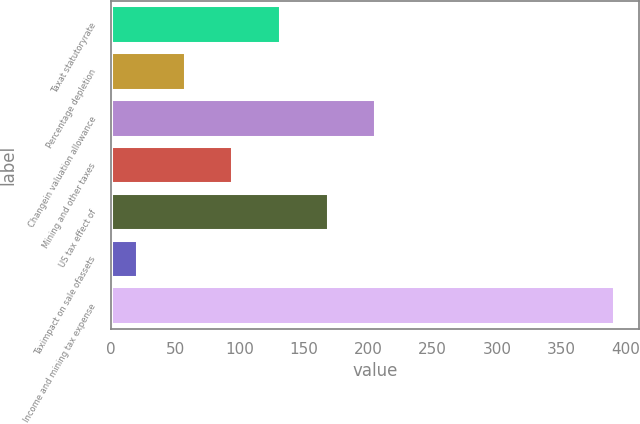<chart> <loc_0><loc_0><loc_500><loc_500><bar_chart><fcel>Taxat statutoryrate<fcel>Percentage depletion<fcel>Changein valuation allowance<fcel>Mining and other taxes<fcel>US tax effect of<fcel>Taximpact on sale ofassets<fcel>Income and mining tax expense<nl><fcel>131.3<fcel>57.1<fcel>205.5<fcel>94.2<fcel>168.4<fcel>20<fcel>391<nl></chart> 